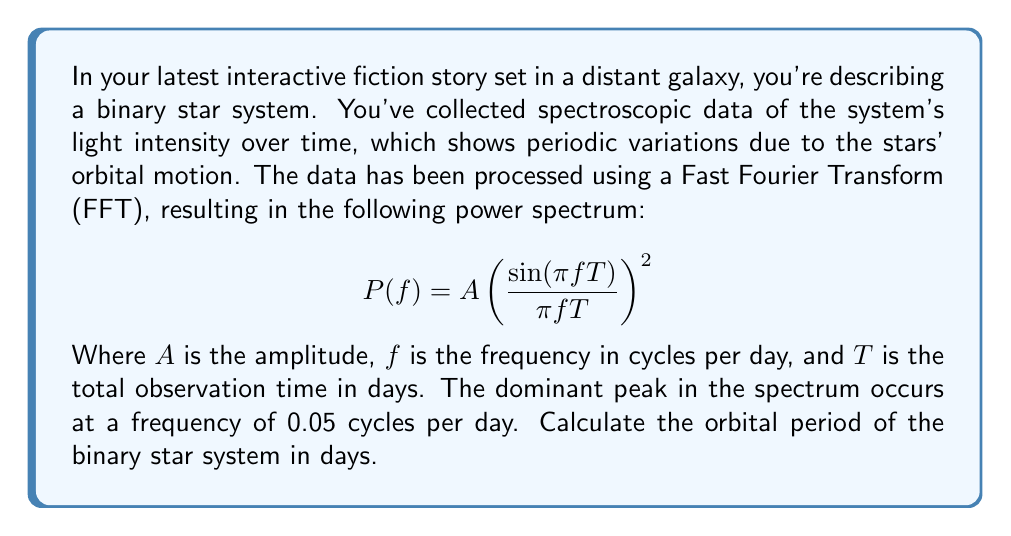Can you solve this math problem? To solve this problem, we need to understand the relationship between frequency and period, and how to interpret the FFT results:

1) The frequency ($f$) is given in cycles per day. This means that the number of cycles completed in one day is 0.05.

2) The period ($P$) is the time taken for one complete cycle. It's the reciprocal of the frequency:

   $$P = \frac{1}{f}$$

3) Given the frequency $f = 0.05$ cycles/day, we can calculate the period:

   $$P = \frac{1}{0.05} = 20 \text{ days}$$

4) This result means that the binary star system completes one full orbit every 20 days.

5) Note: In a real-world scenario, we would need to consider potential aliases and harmonics in the FFT spectrum. The peak at 0.05 cycles/day could represent the fundamental frequency or a harmonic. Additional analysis might be needed to confirm this is indeed the orbital period and not half or double the true period.

6) The sinc-squared function in the power spectrum equation:

   $$\left(\frac{\sin(\pi f T)}{\pi f T}\right)^2$$

   This is characteristic of the spectral leakage due to finite observation time. The width of this function is inversely proportional to the total observation time $T$, which affects the frequency resolution of our measurement.
Answer: The orbital period of the binary star system is 20 days. 